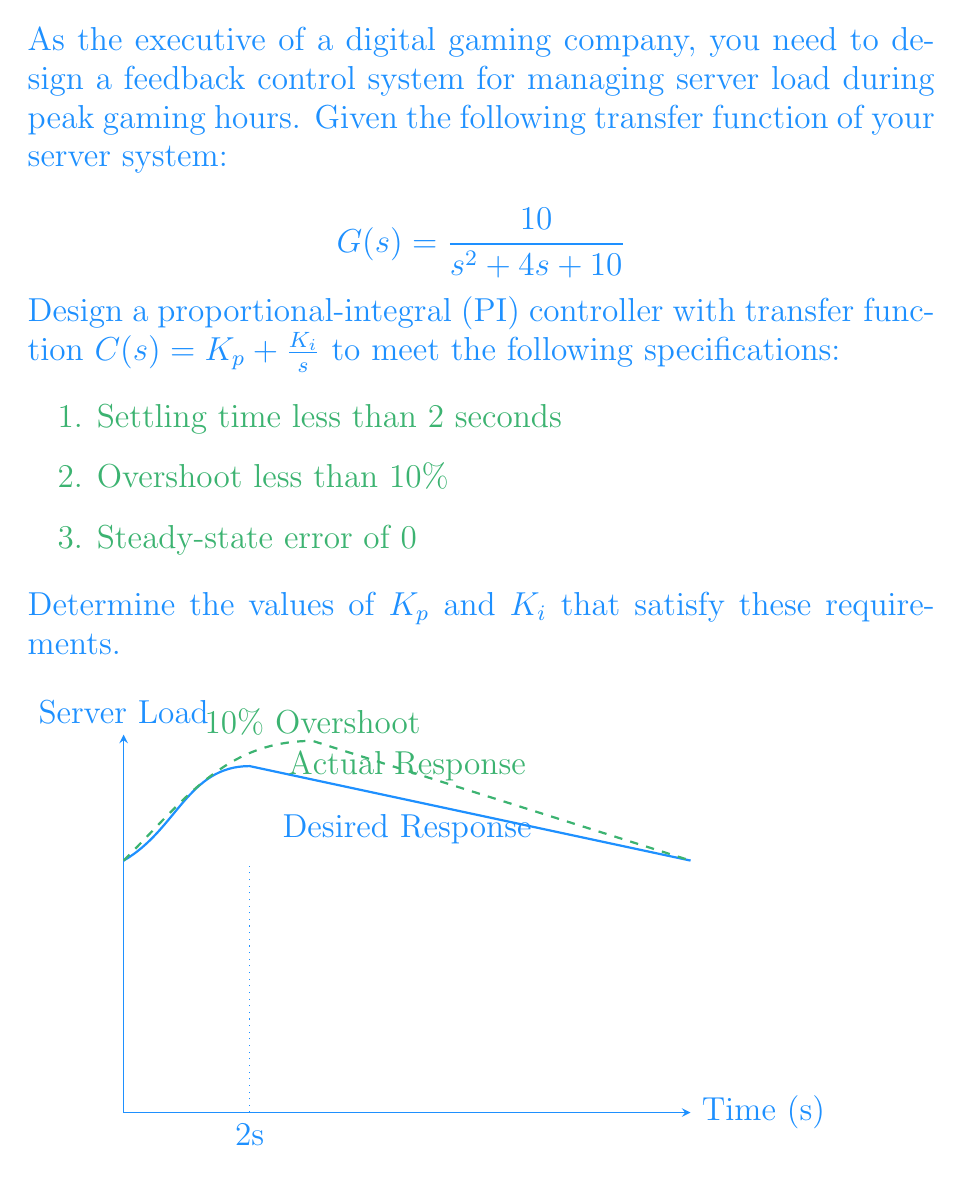Help me with this question. To design the PI controller, we'll follow these steps:

1) The closed-loop transfer function with the PI controller is:

   $$T(s) = \frac{C(s)G(s)}{1 + C(s)G(s)} = \frac{(K_p s + K_i)(10)}{s^3 + 4s^2 + (10+10K_p)s + 10K_i}$$

2) For a second-order approximation, we can compare this to the standard form:

   $$T(s) = \frac{\omega_n^2}{s^2 + 2\zeta\omega_n s + \omega_n^2}$$

3) To achieve an overshoot of less than 10%, we need $\zeta > 0.59$. Let's choose $\zeta = 0.7$.

4) For a settling time less than 2 seconds, we need $\omega_n > \frac{4}{2\zeta T_s} = \frac{4}{2(0.7)(2)} = 1.43$. Let's choose $\omega_n = 2$.

5) Comparing our closed-loop transfer function to the standard form:

   $$s^3 + 4s^2 + (10+10K_p)s + 10K_i = s^3 + 2\zeta\omega_n s^2 + \omega_n^2 s + \alpha\omega_n^3$$

   Where $\alpha$ is chosen to eliminate steady-state error. For a step input, $\alpha = 1$.

6) Equating coefficients:

   $4 = 2\zeta\omega_n = 2(0.7)(2) = 2.8$
   $10 + 10K_p = \omega_n^2 = 4$
   $10K_i = \alpha\omega_n^3 = 1(2^3) = 8$

7) Solving these equations:

   $K_p = \frac{4 - 10}{10} = -0.6$
   $K_i = \frac{8}{10} = 0.8$

Therefore, the PI controller transfer function is:

$$C(s) = -0.6 + \frac{0.8}{s}$$

This controller should meet all the specified requirements.
Answer: $K_p = -0.6$, $K_i = 0.8$ 